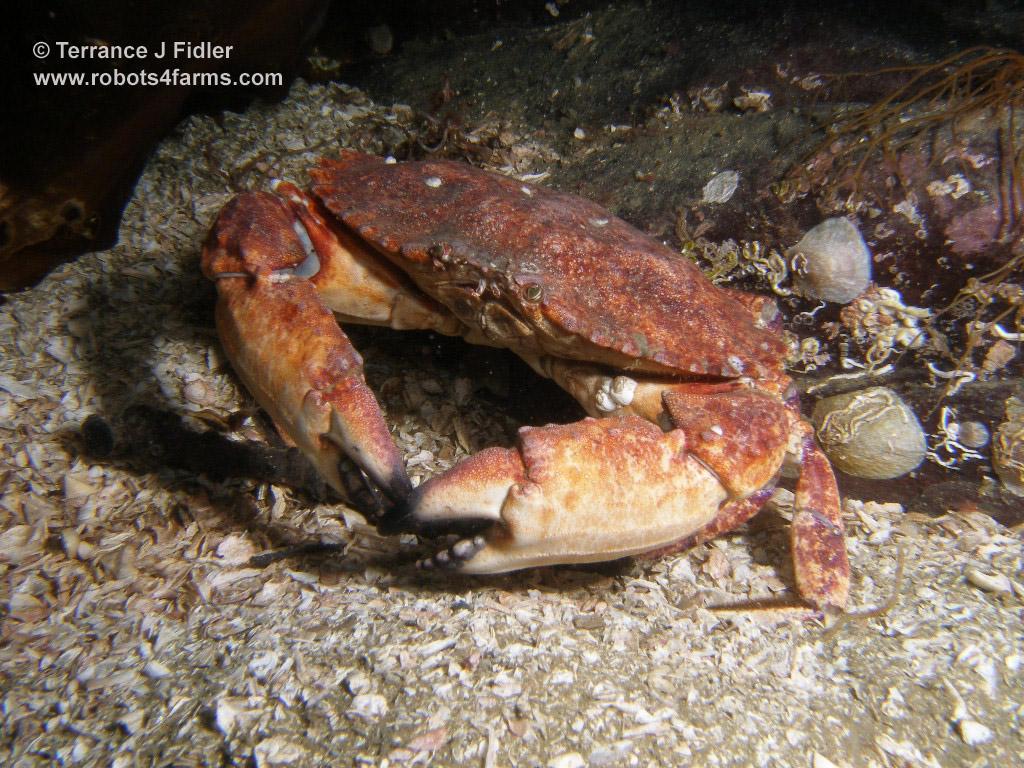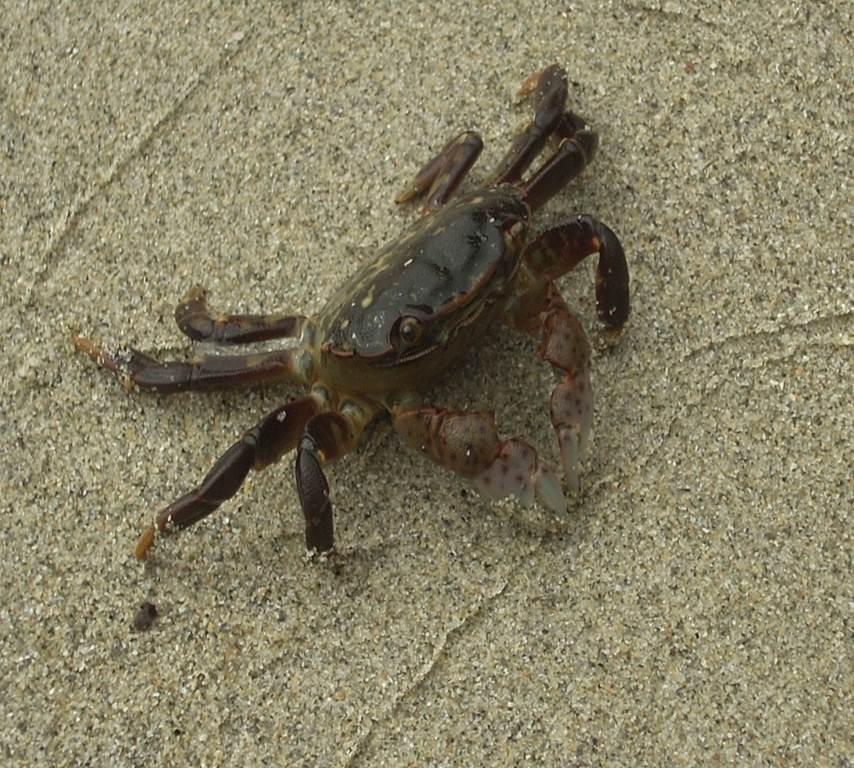The first image is the image on the left, the second image is the image on the right. Assess this claim about the two images: "Each image shows an angled, forward-facing crab that is not held by a person, but the crab on the left is reddish-purple, and the crab on the right is not.". Correct or not? Answer yes or no. Yes. 